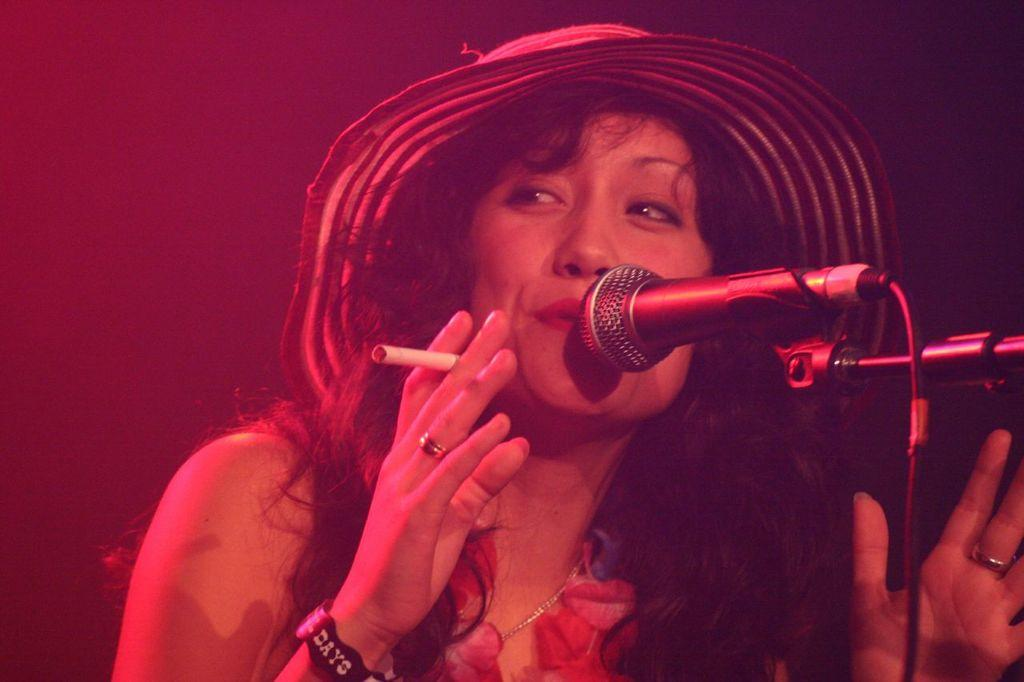What is the main subject of the image? The main subject of the image is a woman. What is the woman doing in the image? The woman is singing in the image. What object is the woman holding while singing? The woman is holding a microphone. What other object is the woman holding in the image? The woman is holding a cigarette. What phase is the moon in during the night depicted in the image? There is no moon or nighttime setting present in the image. What scientific fact can be observed in the image? There is no specific scientific fact observable in the image; it features a woman singing while holding a microphone and a cigarette. 